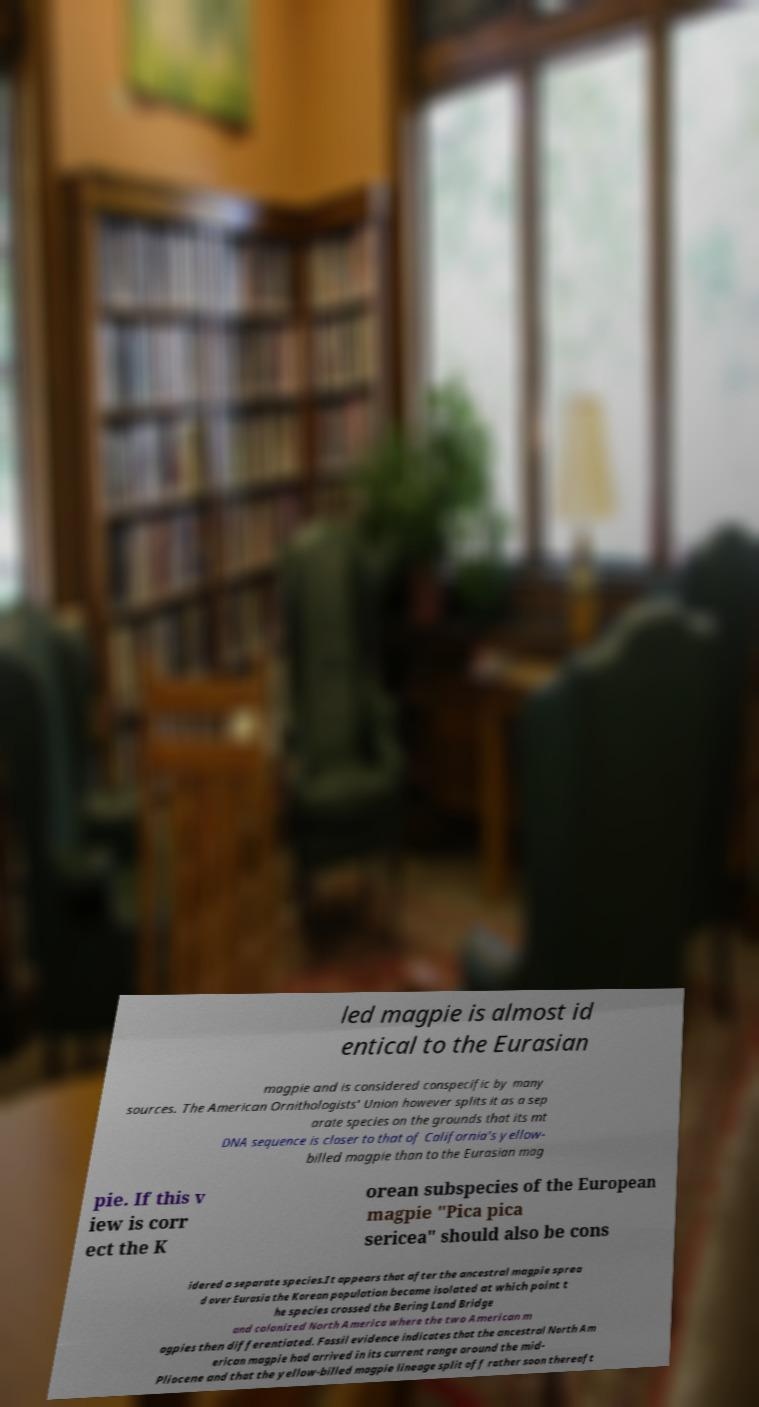Please identify and transcribe the text found in this image. led magpie is almost id entical to the Eurasian magpie and is considered conspecific by many sources. The American Ornithologists' Union however splits it as a sep arate species on the grounds that its mt DNA sequence is closer to that of California's yellow- billed magpie than to the Eurasian mag pie. If this v iew is corr ect the K orean subspecies of the European magpie "Pica pica sericea" should also be cons idered a separate species.It appears that after the ancestral magpie sprea d over Eurasia the Korean population became isolated at which point t he species crossed the Bering Land Bridge and colonized North America where the two American m agpies then differentiated. Fossil evidence indicates that the ancestral North Am erican magpie had arrived in its current range around the mid- Pliocene and that the yellow-billed magpie lineage split off rather soon thereaft 